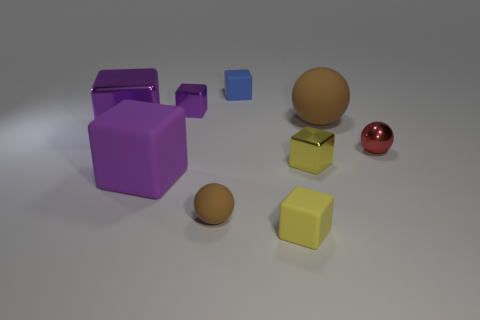Subtract all purple cubes. How many were subtracted if there are1purple cubes left? 2 Subtract all purple cylinders. How many purple cubes are left? 3 Subtract all blue blocks. How many blocks are left? 5 Subtract all small yellow matte blocks. How many blocks are left? 5 Subtract 1 cubes. How many cubes are left? 5 Subtract all green cubes. Subtract all green cylinders. How many cubes are left? 6 Add 1 blue objects. How many objects exist? 10 Subtract all blocks. How many objects are left? 3 Subtract 0 purple cylinders. How many objects are left? 9 Subtract all large purple objects. Subtract all large brown objects. How many objects are left? 6 